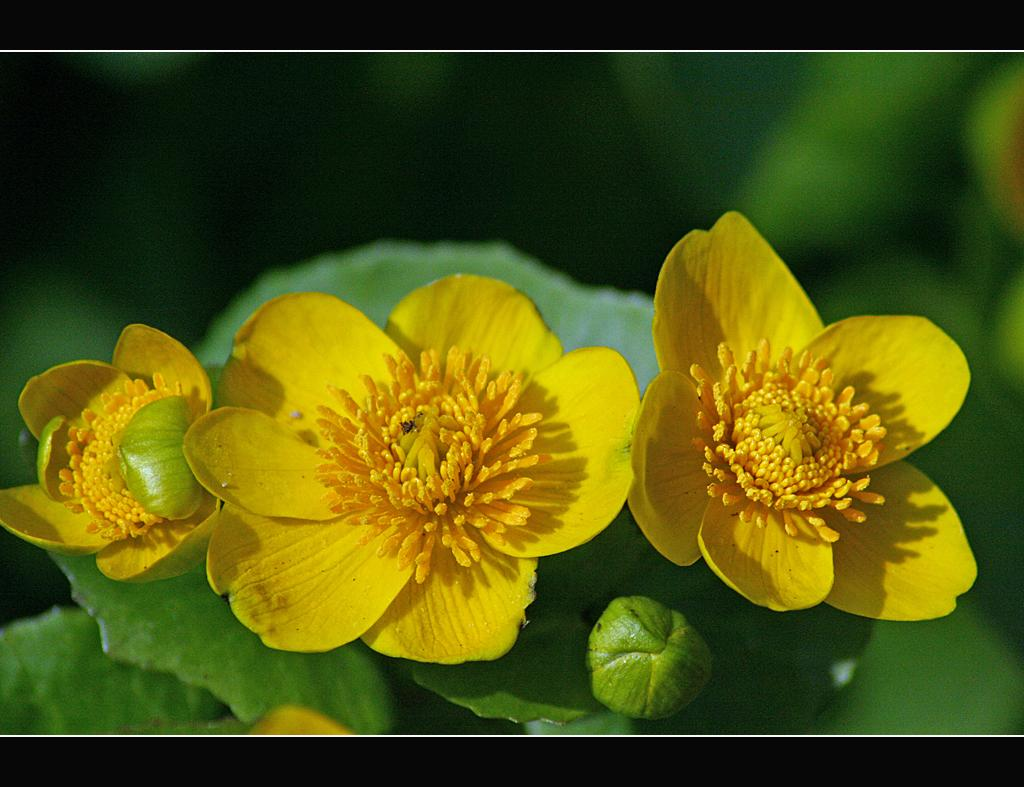What type of flowers can be seen in the image? There are yellow color flowers in the image. What else can be seen in the image besides the flowers? There are leaves and a bud in the image. How is the background of the image depicted? The background of the image is blurred. How many shoes are tied in a knot in the image? There are no shoes or knots present in the image. 